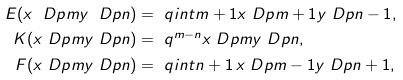Convert formula to latex. <formula><loc_0><loc_0><loc_500><loc_500>E ( x \ D p { m } y \ D p { n } ) & = \ q i n t { m + 1 } x \ D p { m + 1 } y \ D p { n - 1 } , \\ K ( x \ D p { m } y \ D p { n } ) & = \ q ^ { m - n } x \ D p { m } y \ D p { n } , \\ F ( x \ D p { m } y \ D p { n } ) & = \ q i n t { n + 1 } \, x \ D p { m - 1 } y \ D p { n + 1 } ,</formula> 